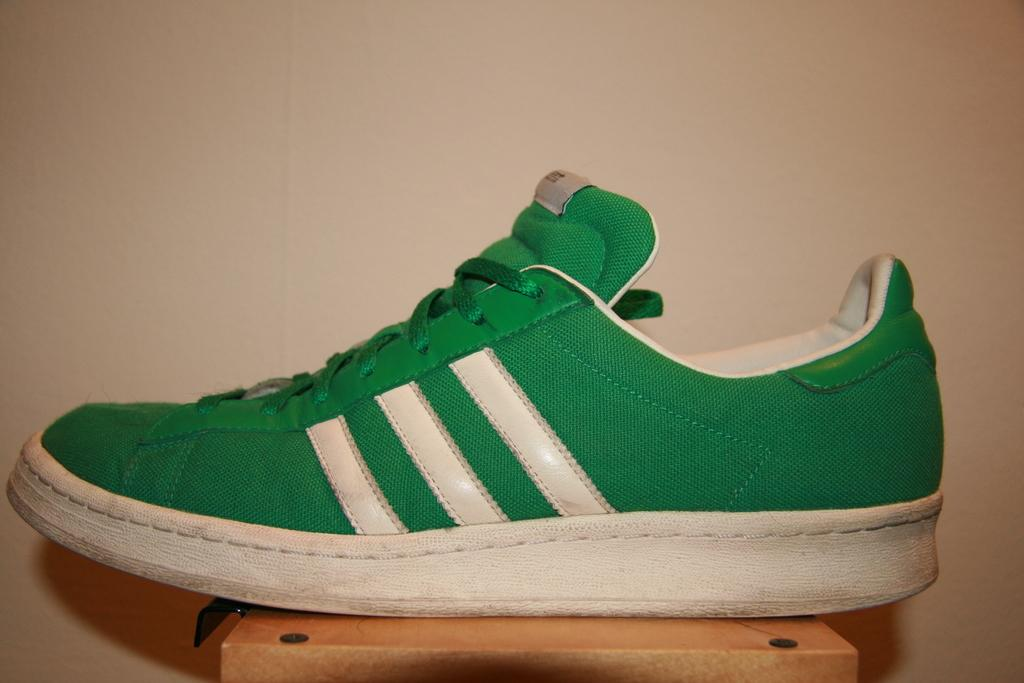What color is the shoe in the image? The shoe in the image is green. What is the shoe placed on? The shoe is on a wooden block. What can be seen in the background of the image? There is a wall in the background of the image. What type of knowledge is being shared in the image? There is no indication of knowledge sharing in the image; it features a green shoe on a wooden block with a wall in the background. 